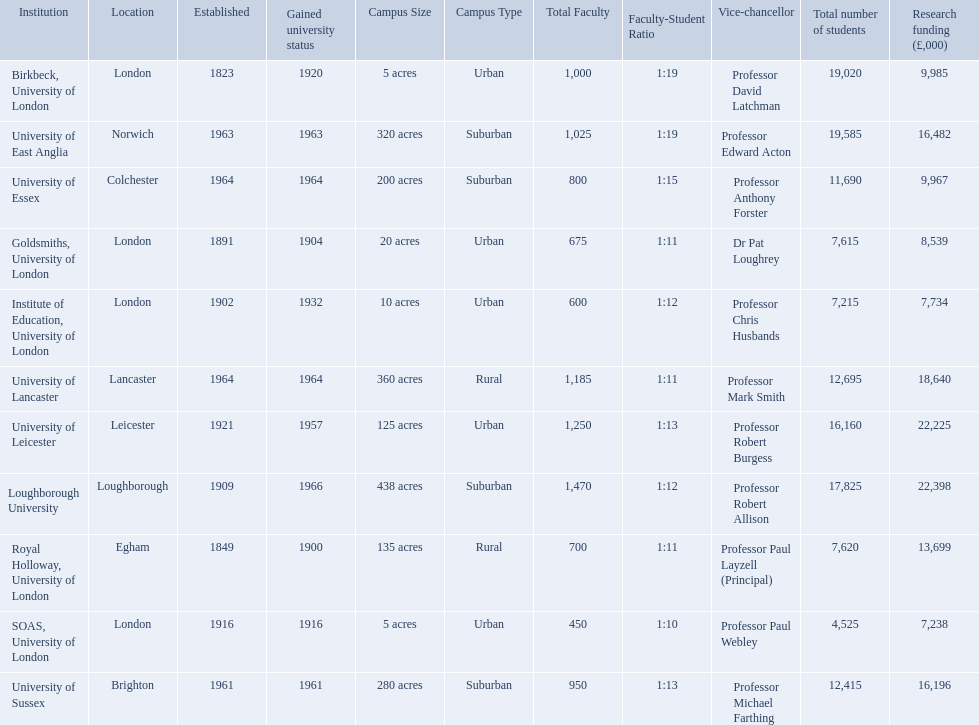Where is birbeck,university of london located? London. Which university was established in 1921? University of Leicester. Which institution gained university status recently? Loughborough University. 